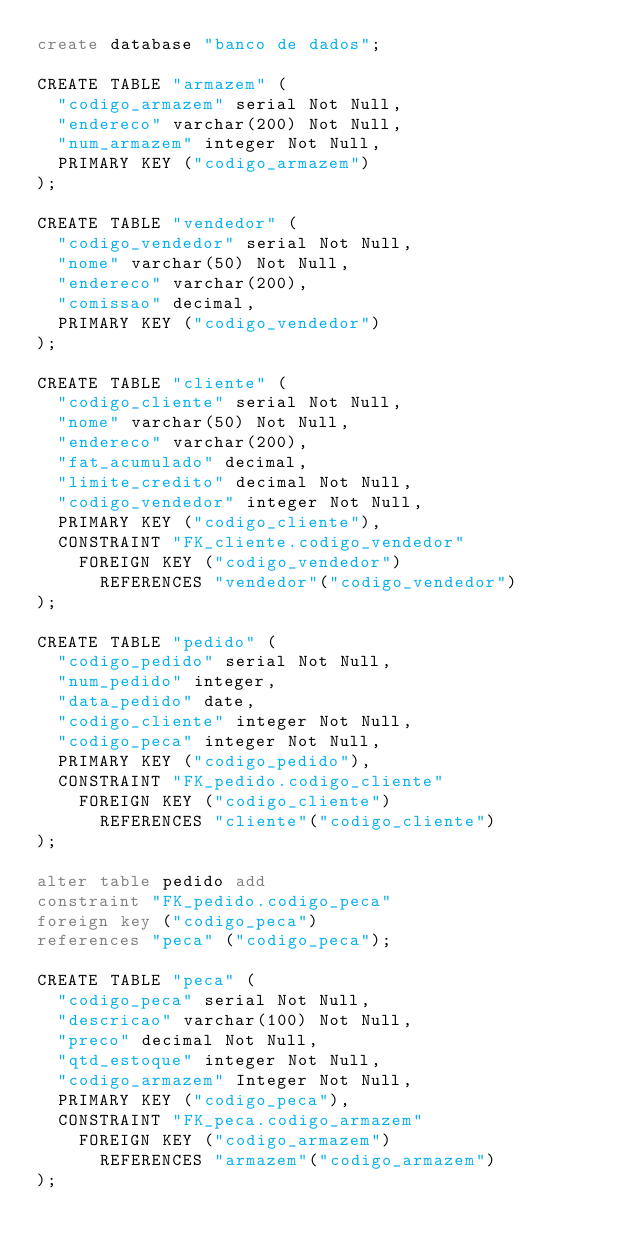<code> <loc_0><loc_0><loc_500><loc_500><_SQL_>create database "banco de dados";

CREATE TABLE "armazem" (
  "codigo_armazem" serial Not Null,
  "endereco" varchar(200) Not Null,
  "num_armazem" integer Not Null,
  PRIMARY KEY ("codigo_armazem")
);

CREATE TABLE "vendedor" (
  "codigo_vendedor" serial Not Null,
  "nome" varchar(50) Not Null,
  "endereco" varchar(200),
  "comissao" decimal,
  PRIMARY KEY ("codigo_vendedor")
);

CREATE TABLE "cliente" (
  "codigo_cliente" serial Not Null,
  "nome" varchar(50) Not Null,
  "endereco" varchar(200),
  "fat_acumulado" decimal,
  "limite_credito" decimal Not Null,
  "codigo_vendedor" integer Not Null,
  PRIMARY KEY ("codigo_cliente"),
  CONSTRAINT "FK_cliente.codigo_vendedor"
    FOREIGN KEY ("codigo_vendedor")
      REFERENCES "vendedor"("codigo_vendedor")
);

CREATE TABLE "pedido" (
  "codigo_pedido" serial Not Null,
  "num_pedido" integer,
  "data_pedido" date,
  "codigo_cliente" integer Not Null,
  "codigo_peca" integer Not Null,
  PRIMARY KEY ("codigo_pedido"),
  CONSTRAINT "FK_pedido.codigo_cliente"
    FOREIGN KEY ("codigo_cliente")
      REFERENCES "cliente"("codigo_cliente")
);

alter table pedido add 
constraint "FK_pedido.codigo_peca" 
foreign key ("codigo_peca") 
references "peca" ("codigo_peca");

CREATE TABLE "peca" (
  "codigo_peca" serial Not Null,
  "descricao" varchar(100) Not Null,
  "preco" decimal Not Null,
  "qtd_estoque" integer Not Null,
  "codigo_armazem" Integer Not Null,
  PRIMARY KEY ("codigo_peca"),
  CONSTRAINT "FK_peca.codigo_armazem"
    FOREIGN KEY ("codigo_armazem")
      REFERENCES "armazem"("codigo_armazem")
);

</code> 